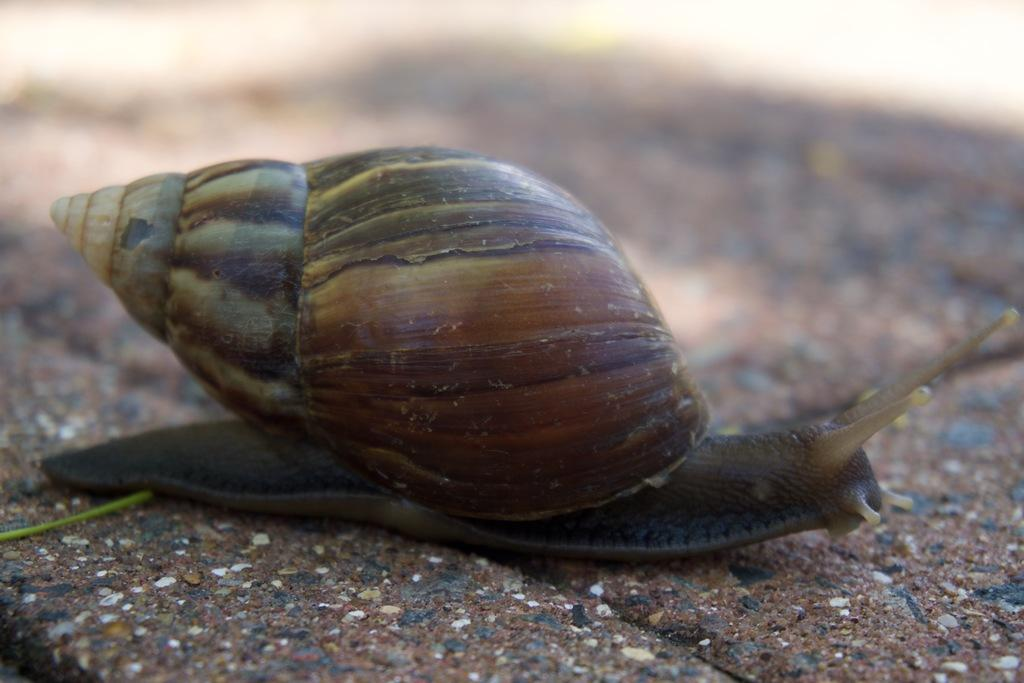What is the main subject of the picture? The main subject of the picture is a snail. Where is the snail located in the image? The snail is on a path in the image. What is the snail carrying on its back? The snail has a shell on top of it. What type of trousers is the snail wearing in the image? Snails do not wear trousers, as they are invertebrates without limbs or clothing. 